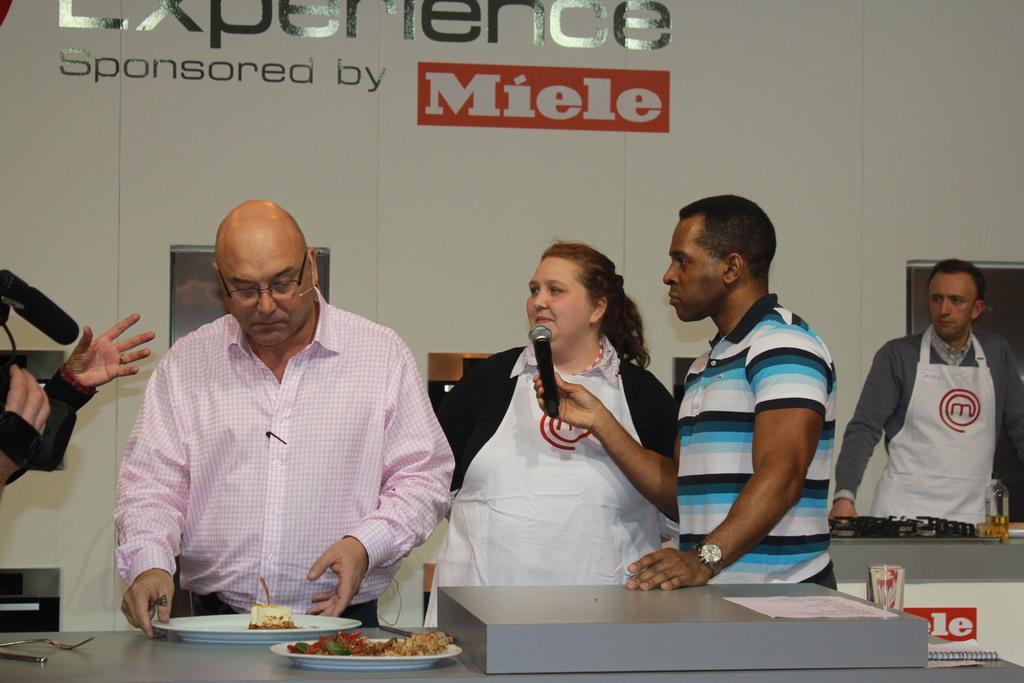Can you describe this image briefly? In this image I can see group of people standing. The person in front wearing white color apron and the person at right holding a microphone, in front I can see food in the plate and the plate is in white color. Background I can see a board in white color. 